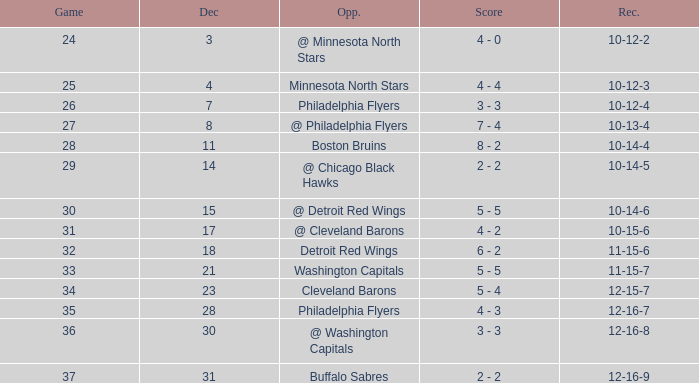What is Record, when Game is "24"? 10-12-2. 